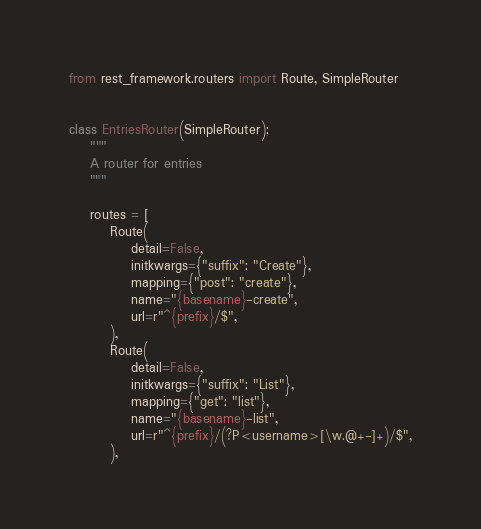<code> <loc_0><loc_0><loc_500><loc_500><_Python_>from rest_framework.routers import Route, SimpleRouter


class EntriesRouter(SimpleRouter):
    """
    A router for entries
    """

    routes = [
        Route(
            detail=False,
            initkwargs={"suffix": "Create"},
            mapping={"post": "create"},
            name="{basename}-create",
            url=r"^{prefix}/$",
        ),
        Route(
            detail=False,
            initkwargs={"suffix": "List"},
            mapping={"get": "list"},
            name="{basename}-list",
            url=r"^{prefix}/(?P<username>[\w.@+-]+)/$",
        ),</code> 